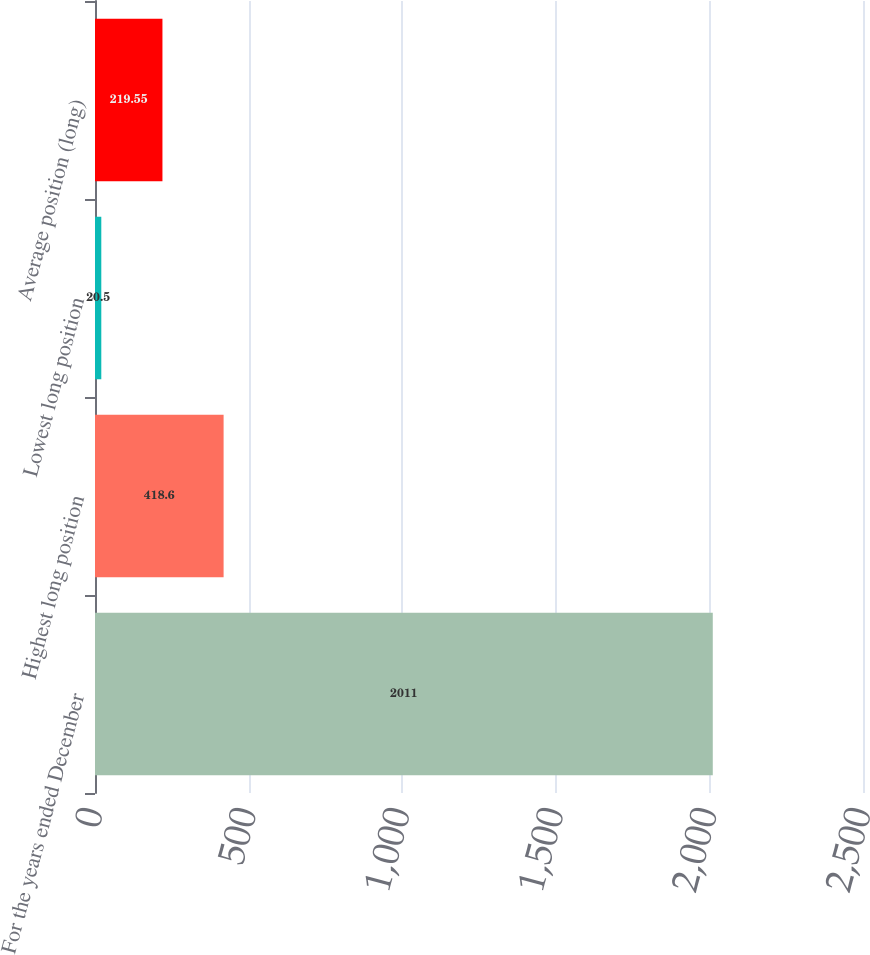<chart> <loc_0><loc_0><loc_500><loc_500><bar_chart><fcel>For the years ended December<fcel>Highest long position<fcel>Lowest long position<fcel>Average position (long)<nl><fcel>2011<fcel>418.6<fcel>20.5<fcel>219.55<nl></chart> 